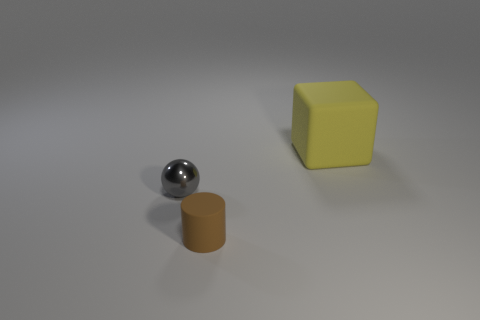Add 2 big red matte things. How many objects exist? 5 Subtract all cyan blocks. Subtract all brown balls. How many blocks are left? 1 Subtract all cylinders. How many objects are left? 2 Add 3 tiny gray cylinders. How many tiny gray cylinders exist? 3 Subtract 0 red spheres. How many objects are left? 3 Subtract all small balls. Subtract all tiny metal things. How many objects are left? 1 Add 1 tiny brown rubber things. How many tiny brown rubber things are left? 2 